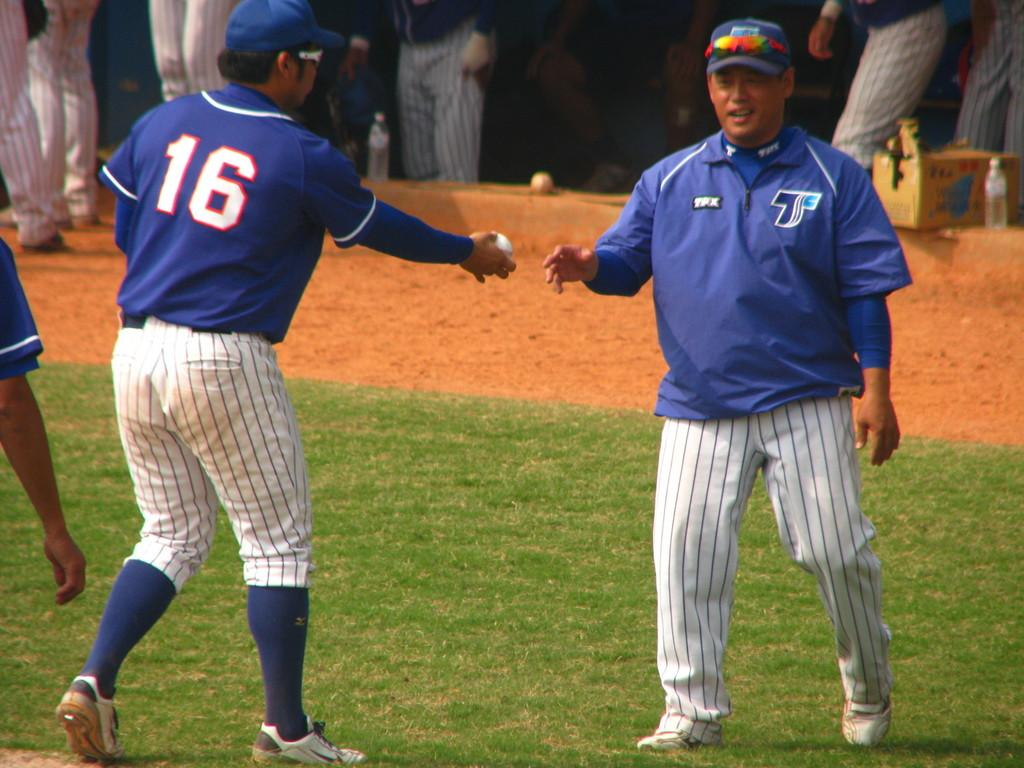<image>
Present a compact description of the photo's key features. A baseball player on a field with the number 16 on his jersey 